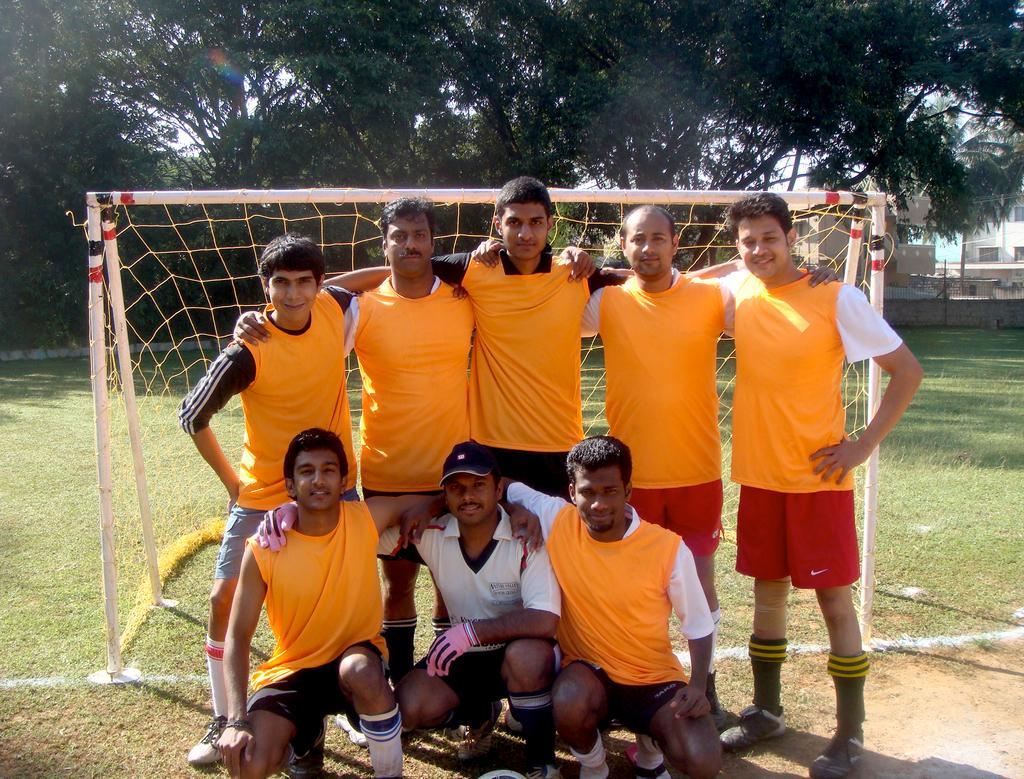Can you describe this image briefly? In this image in the center there are some people who are standing and some of them are sitting on their knees, and in the background there is a net and some poles. At the bottom there is grass and on the right side there are some houses, on the top of the image there are some trees. 